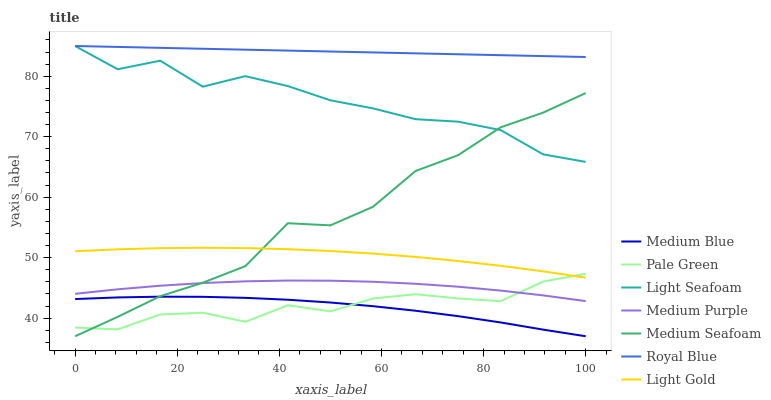Does Medium Blue have the minimum area under the curve?
Answer yes or no. Yes. Does Royal Blue have the maximum area under the curve?
Answer yes or no. Yes. Does Medium Purple have the minimum area under the curve?
Answer yes or no. No. Does Medium Purple have the maximum area under the curve?
Answer yes or no. No. Is Royal Blue the smoothest?
Answer yes or no. Yes. Is Light Seafoam the roughest?
Answer yes or no. Yes. Is Medium Purple the smoothest?
Answer yes or no. No. Is Medium Purple the roughest?
Answer yes or no. No. Does Medium Blue have the lowest value?
Answer yes or no. Yes. Does Medium Purple have the lowest value?
Answer yes or no. No. Does Light Seafoam have the highest value?
Answer yes or no. Yes. Does Medium Purple have the highest value?
Answer yes or no. No. Is Medium Purple less than Light Gold?
Answer yes or no. Yes. Is Royal Blue greater than Pale Green?
Answer yes or no. Yes. Does Light Seafoam intersect Medium Seafoam?
Answer yes or no. Yes. Is Light Seafoam less than Medium Seafoam?
Answer yes or no. No. Is Light Seafoam greater than Medium Seafoam?
Answer yes or no. No. Does Medium Purple intersect Light Gold?
Answer yes or no. No. 